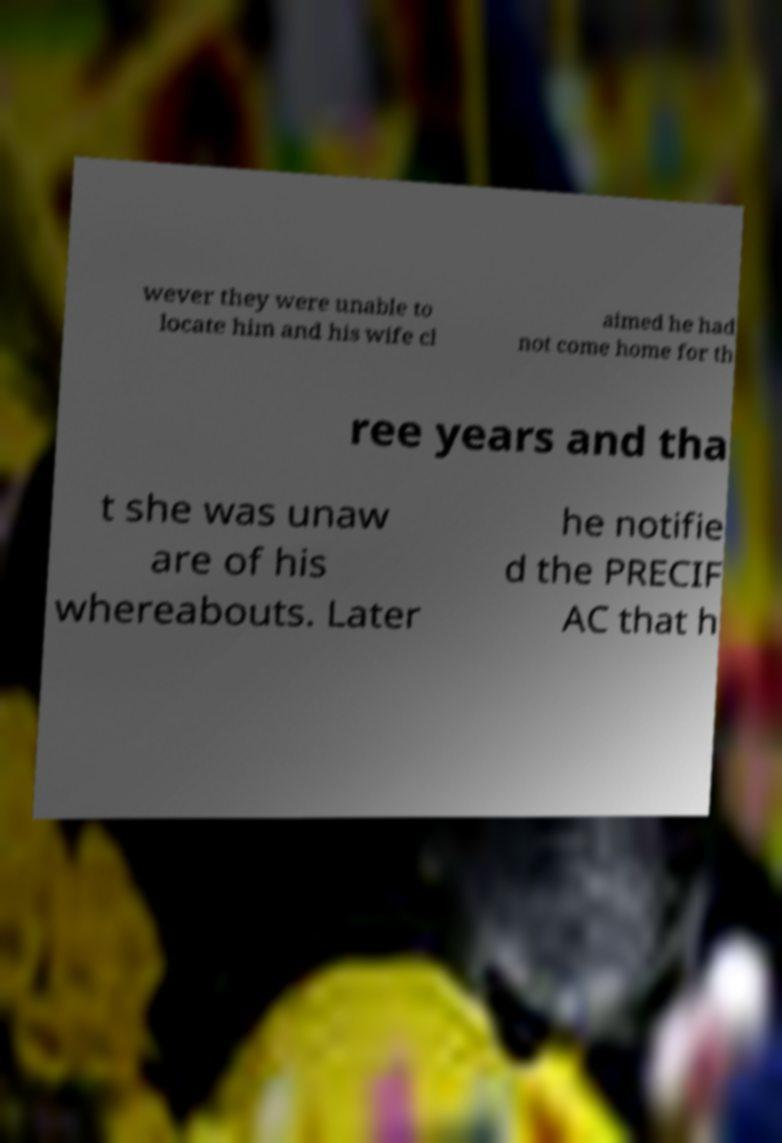Can you accurately transcribe the text from the provided image for me? wever they were unable to locate him and his wife cl aimed he had not come home for th ree years and tha t she was unaw are of his whereabouts. Later he notifie d the PRECIF AC that h 